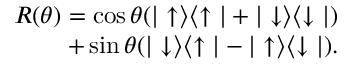Convert formula to latex. <formula><loc_0><loc_0><loc_500><loc_500>\begin{array} { r } { R ( \theta ) = \cos { \theta } ( | \uparrow \rangle \langle \uparrow | + | \downarrow \rangle \langle \downarrow | ) } \\ { + \sin { \theta } ( | \downarrow \rangle \langle \uparrow | - | \uparrow \rangle \langle \downarrow | ) . } \end{array}</formula> 